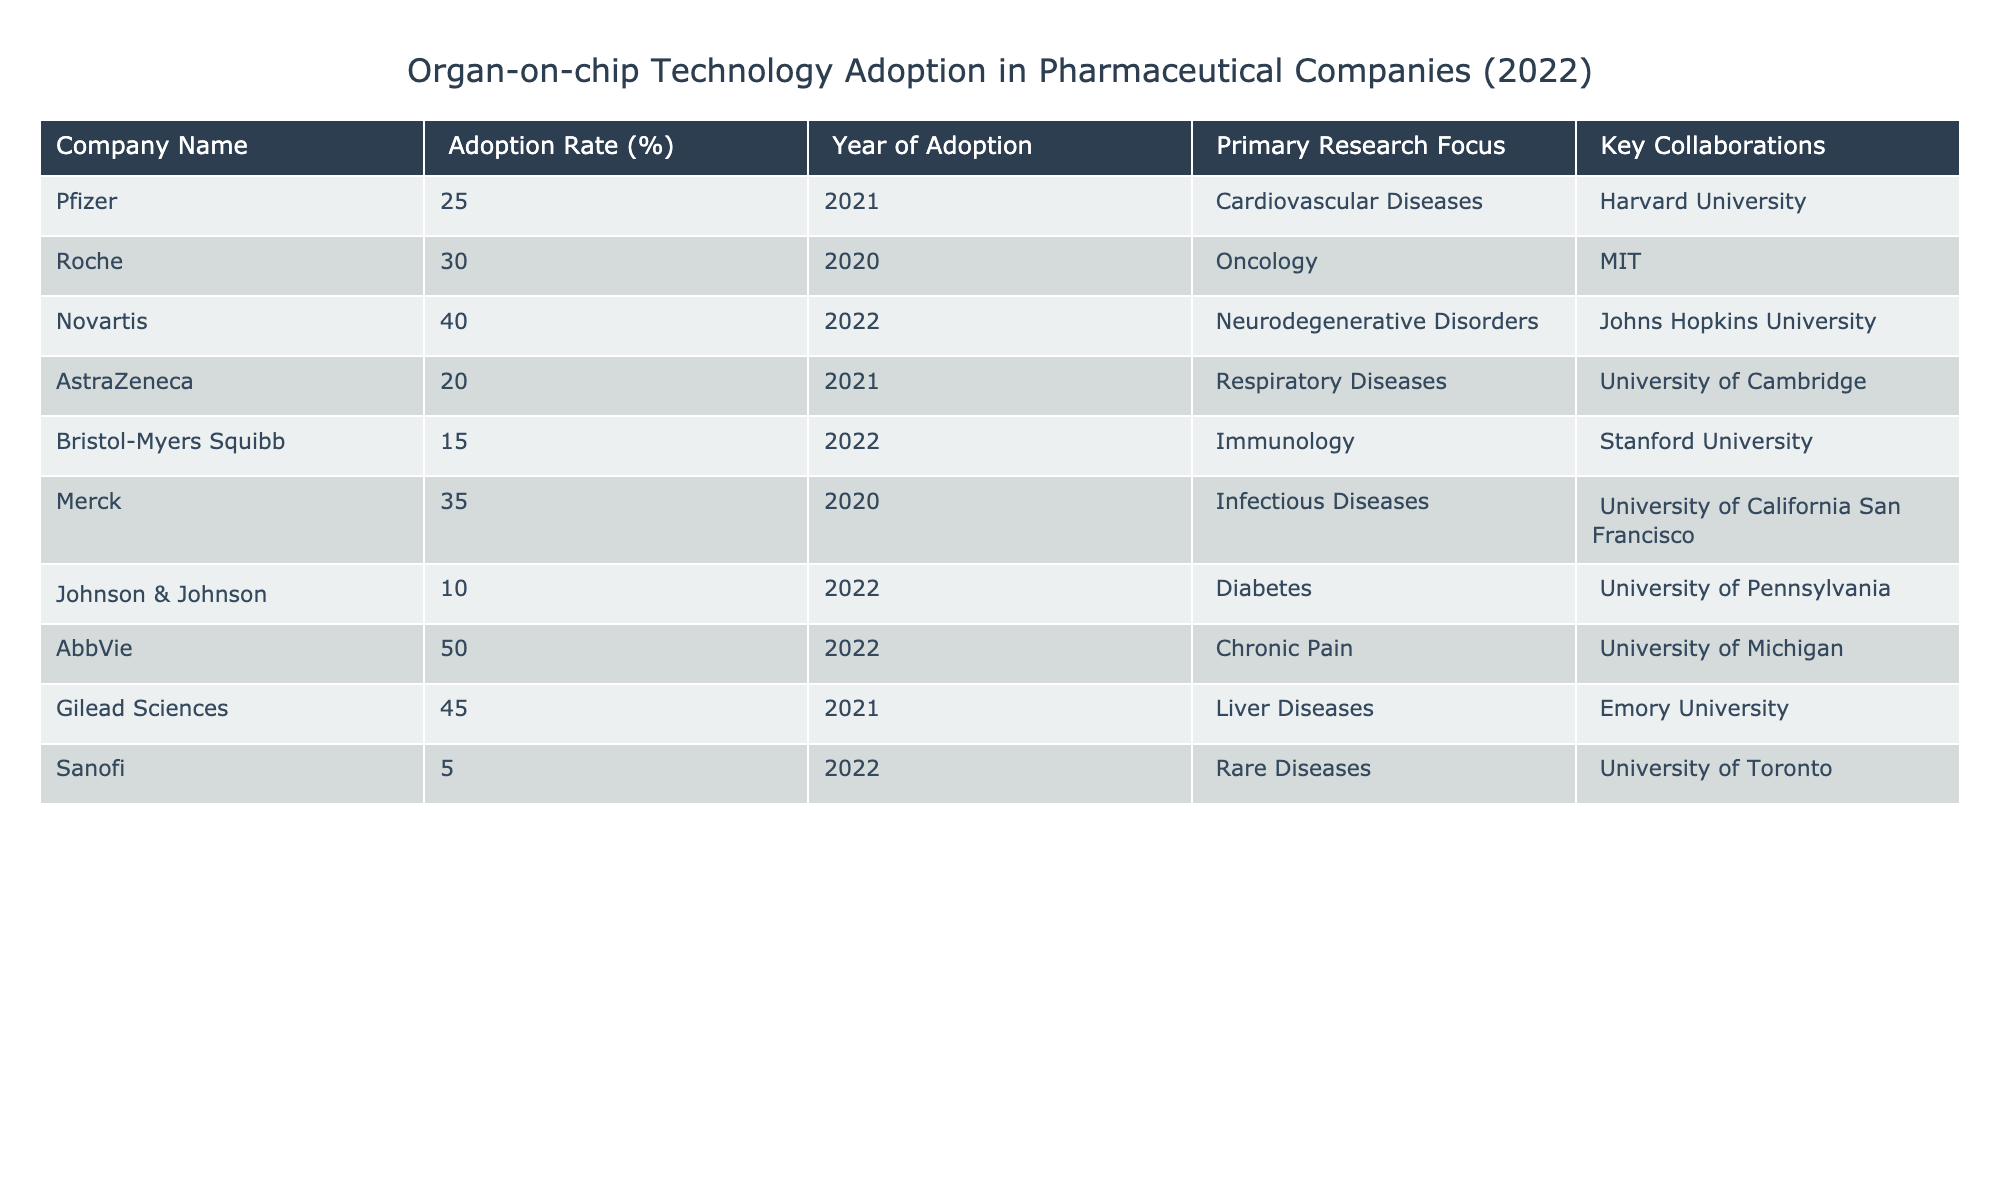What is the adoption rate of AbbVie? The table lists AbbVie's adoption rate directly under the "Adoption Rate (%)" column. According to the data, AbbVie's adoption rate is 50%.
Answer: 50% Which company has the lowest adoption rate? By examining the "Adoption Rate (%)" column, Sanofi is listed with the lowest adoption rate of 5%.
Answer: 5% What is the primary research focus of Gilead Sciences? Looking at the "Primary Research Focus" column for Gilead Sciences, it states "Liver Diseases."
Answer: Liver Diseases How many companies adopted organ-on-chip technology in 2022? By checking the "Year of Adoption" column and counting the entries for the year 2022, we find that there are four companies: Novartis, Bristol-Myers Squibb, Johnson & Johnson, and AbbVie.
Answer: 4 What is the average adoption rate of companies that focus on diseases related to the nervous system? Novartis, which focuses on neurodegenerative disorders, has an adoption rate of 40%. This is the only entry related to the nervous system, so the average adoption rate is simply 40%.
Answer: 40% Does Roche have a higher adoption rate than Johnson & Johnson? Comparing Roche's adoption rate of 30% to Johnson & Johnson's rate of 10%, it is clear that Roche's rate is higher.
Answer: Yes What is the difference in adoption rates between the company with the highest adoption rate and the company with the lowest adoption rate? AbbVie, with the highest adoption rate of 50%, and Sanofi, with the lowest adoption rate of 5%, exhibit a difference in adoption rates calculated as 50% - 5% = 45%.
Answer: 45% Which universities are collaborators for the companies with an adoption rate greater than 30%? The companies with adoption rates above 30% are Novartis, Merck, Gilead Sciences, and AbbVie. Their collaborators are Johns Hopkins University, University of California San Francisco, Emory University, and University of Michigan, respectively.
Answer: Johns Hopkins University, University of California San Francisco, Emory University, University of Michigan What percentage of companies listed focus on diseases with an adoption rate of 20% or lower? The companies with an adoption rate of 20% or lower are AstraZeneca (20%), Bristol-Myers Squibb (15%), Johnson & Johnson (10%), and Sanofi (5%)—a total of 4 out of 10 companies, which is 40%.
Answer: 40% 